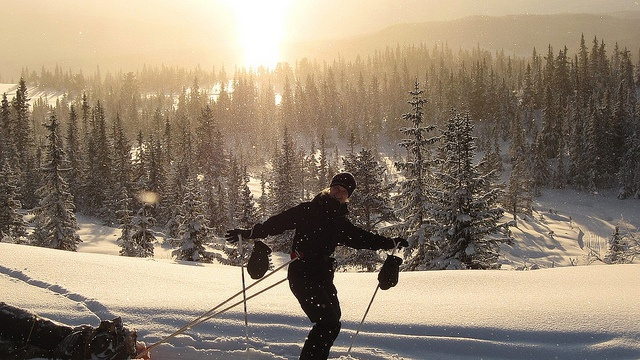Describe the objects in this image and their specific colors. I can see people in tan, black, gray, and beige tones in this image. 